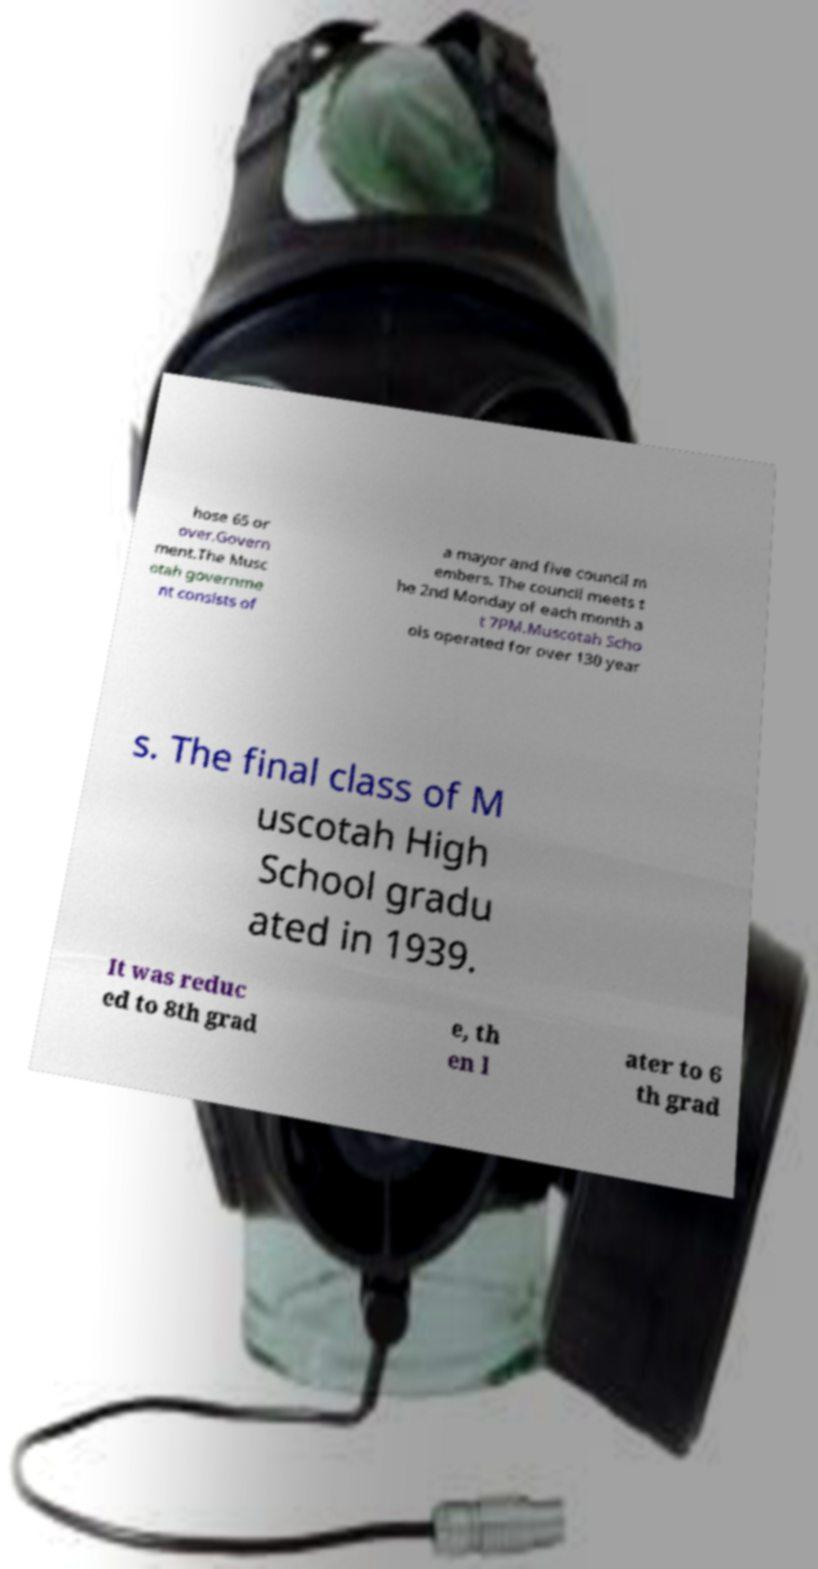Could you extract and type out the text from this image? hose 65 or over.Govern ment.The Musc otah governme nt consists of a mayor and five council m embers. The council meets t he 2nd Monday of each month a t 7PM.Muscotah Scho ols operated for over 130 year s. The final class of M uscotah High School gradu ated in 1939. It was reduc ed to 8th grad e, th en l ater to 6 th grad 